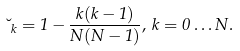Convert formula to latex. <formula><loc_0><loc_0><loc_500><loc_500>\lambda _ { k } = 1 - \frac { k ( k - 1 ) } { N ( N - 1 ) } , \, k = 0 \dots N .</formula> 